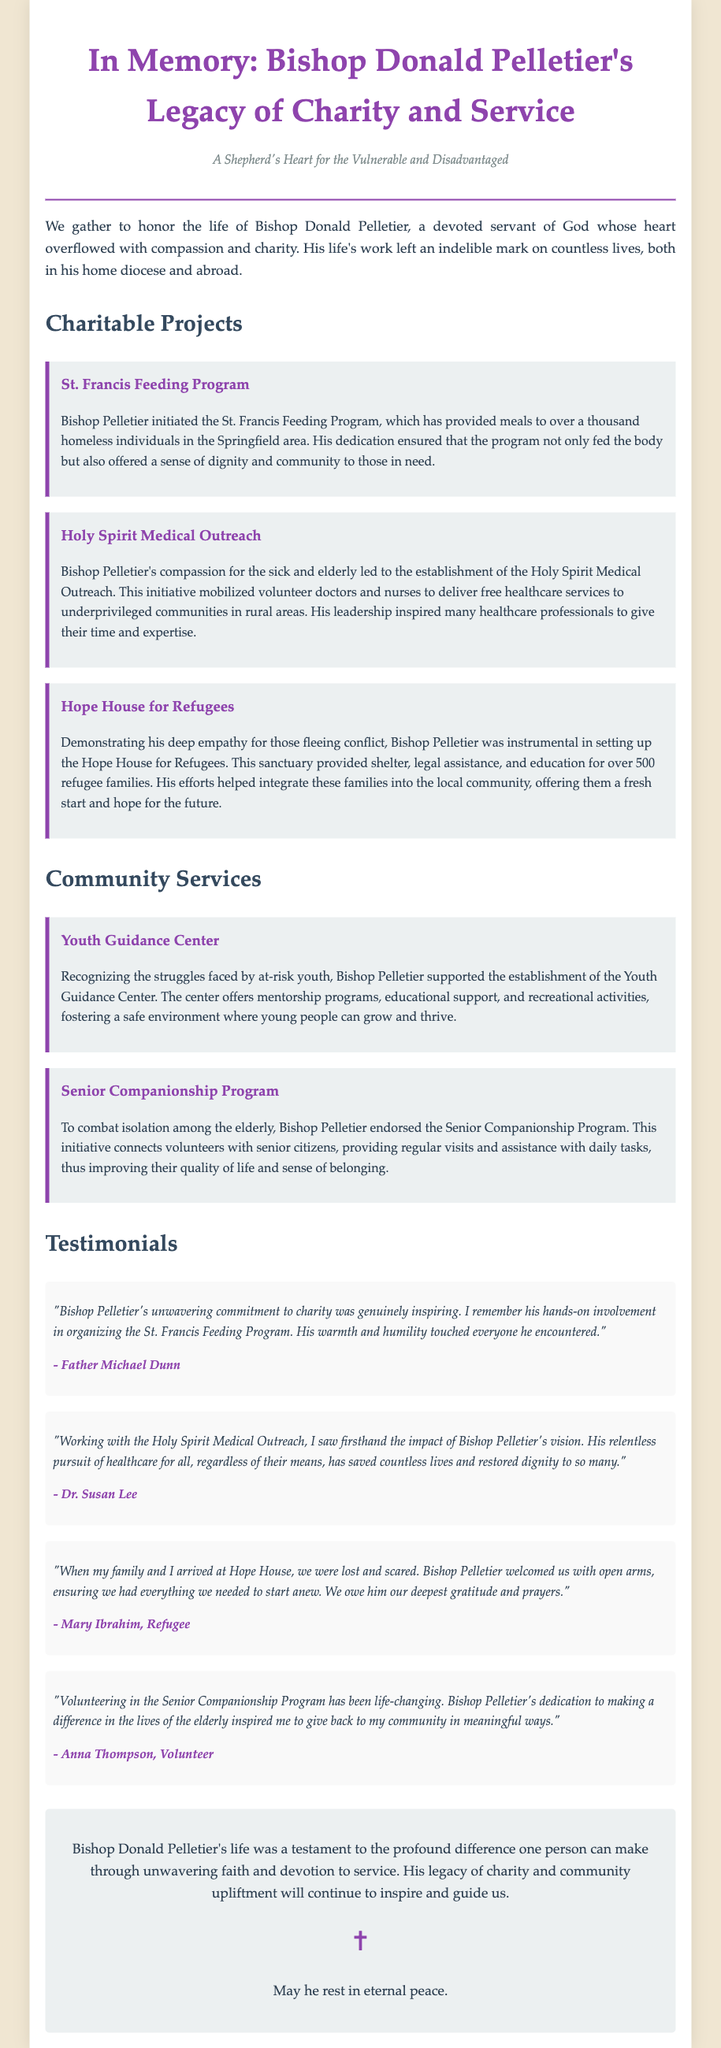What charitable program did Bishop Pelletier initiate to help the homeless? The document states that Bishop Pelletier initiated the St. Francis Feeding Program to provide meals to the homeless.
Answer: St. Francis Feeding Program How many refugee families benefitted from the Hope House? The document mentions that the Hope House provided shelter and assistance to over 500 refugee families.
Answer: Over 500 Who was inspired by Bishop Pelletier's vision for the Holy Spirit Medical Outreach? The document includes a testimonial from Dr. Susan Lee, who saw firsthand the impact of Bishop Pelletier's vision.
Answer: Dr. Susan Lee What type of support does the Youth Guidance Center offer? The document describes that the Youth Guidance Center offers mentorship programs, educational support, and recreational activities.
Answer: Mentorship programs, educational support, recreational activities Which program aims to connect volunteers with senior citizens? The document states that the Senior Companionship Program connects volunteers with seniors to combat isolation.
Answer: Senior Companionship Program What was Bishop Pelletier's approach towards the elderly as described in the document? The document explains that he endorsed the Senior Companionship Program to improve the quality of life for elderly citizens.
Answer: Improving quality of life What is a common theme across Bishop Pelletier's charitable projects? The document highlights the recurring theme of compassion and dignity in all of Bishop Pelletier's initiatives.
Answer: Compassion and dignity What role did volunteers play in the Holy Spirit Medical Outreach? According to the document, volunteer doctors and nurses were mobilized to deliver free healthcare services through the initiative.
Answer: Deliver free healthcare services Which project emphasizes education and legal assistance for refugees? The document specifically describes the Hope House for Refugees, which provides shelter, legal assistance, and education.
Answer: Hope House for Refugees 